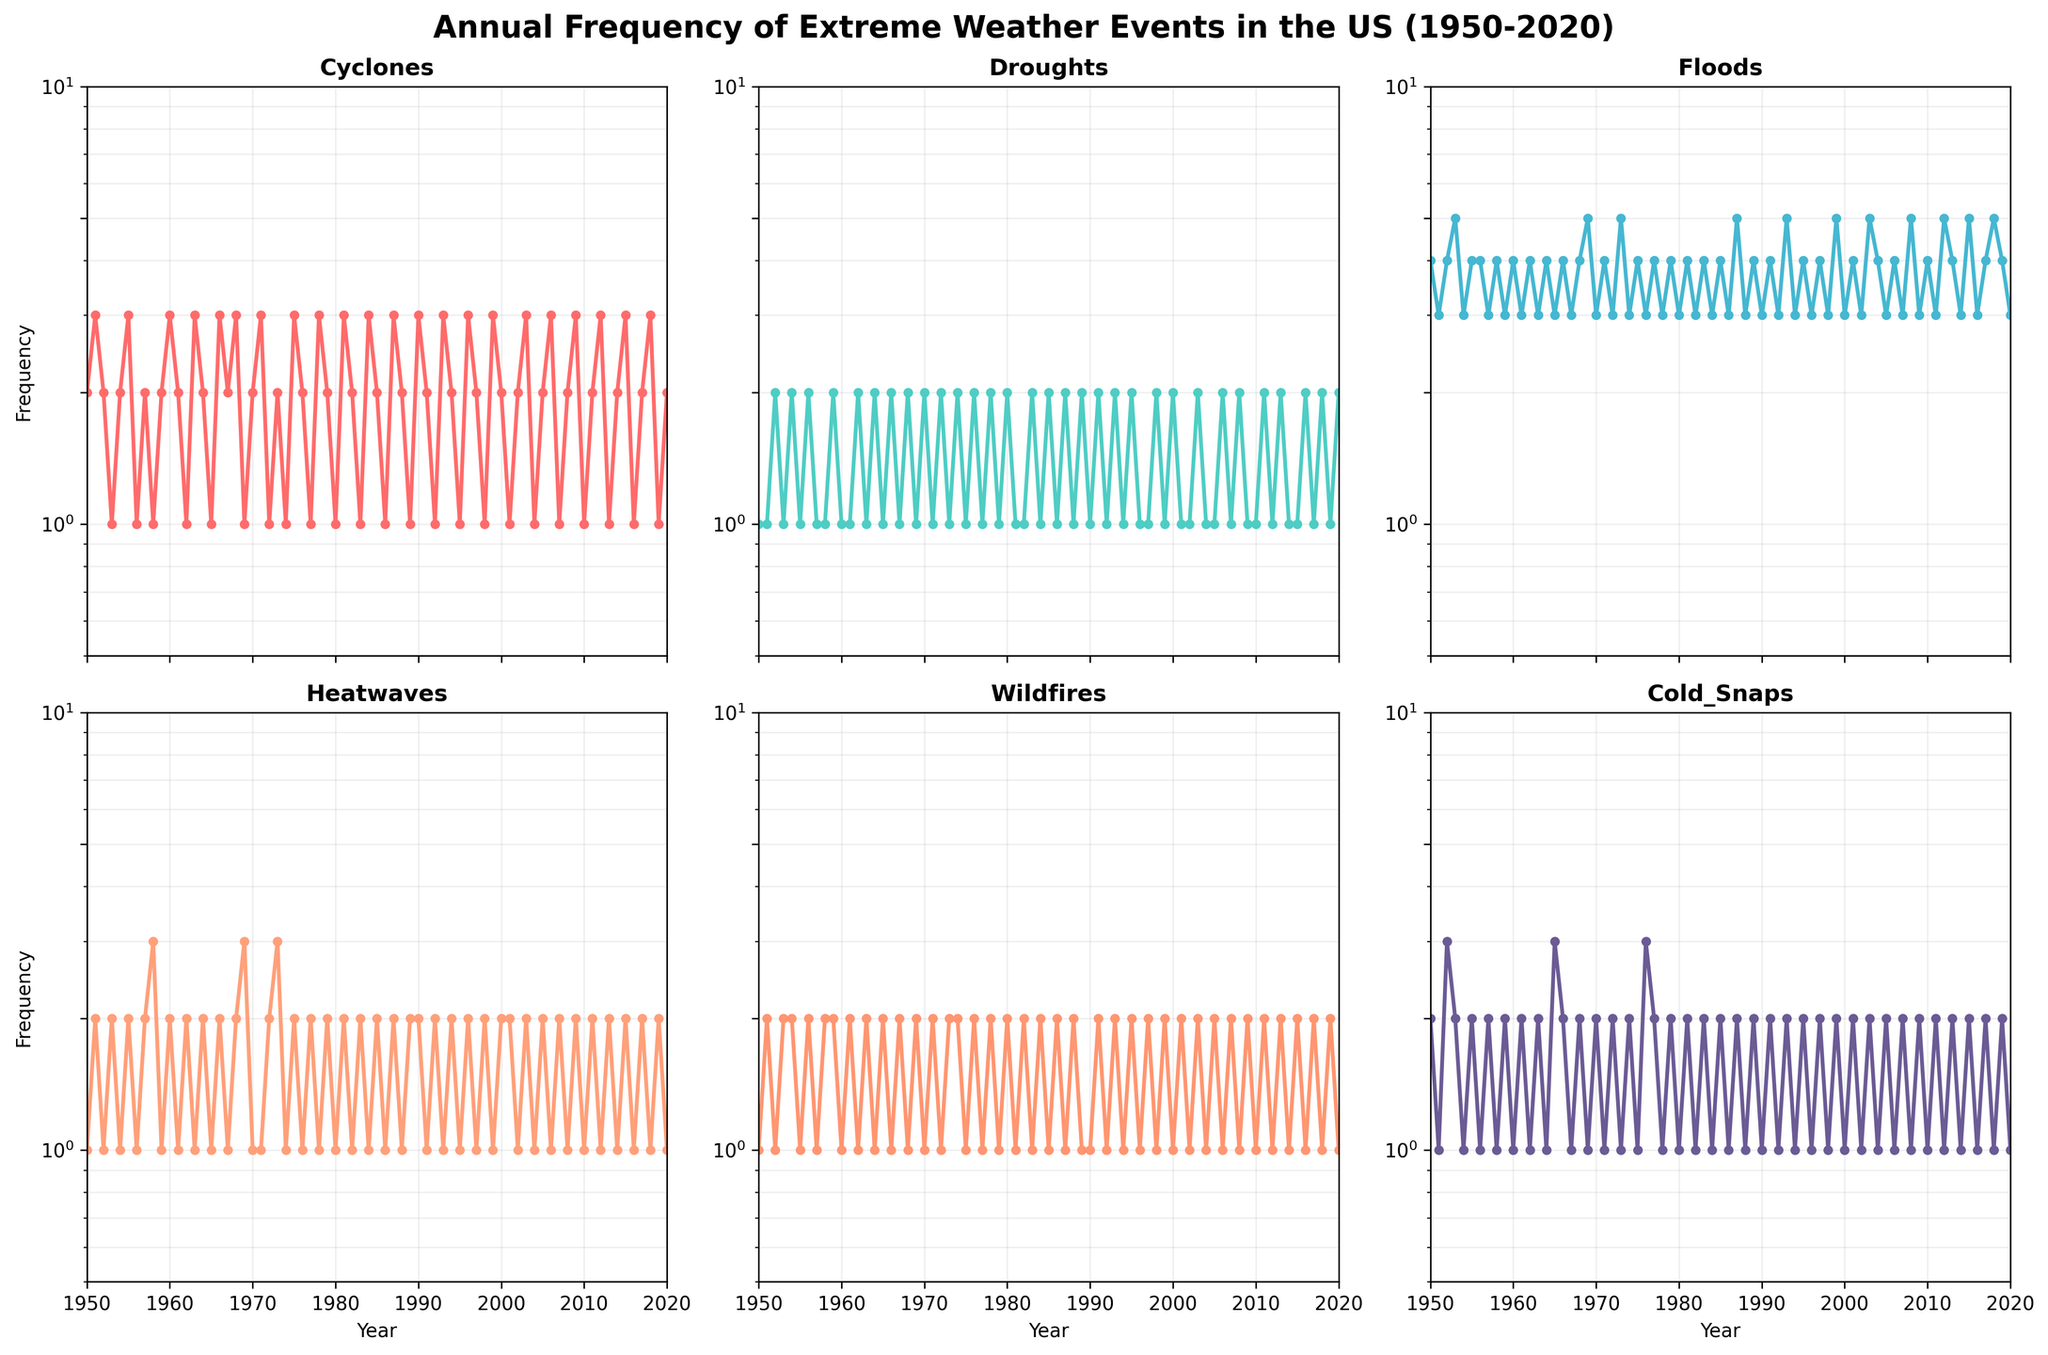What is the overall trend of cyclones from 1950 to 2020? The Cyclones subplot shows the frequency of cyclones over the years from 1950 to 2020. By observing the plot, we can identify any upward or downward trends in the frequency. The frequency of cyclones seems relatively consistent over the years without a strong increasing or decreasing trend.
Answer: Relatively consistent During which decade did wildfires occur most frequently? By looking at the Wildfires subplot, we can compare the frequency of events in each decade to identify which decade had the highest occurrence. The 2010s had the highest frequency of wildfires, with values often at or above 2 per year.
Answer: 2010s Which event had the most noticeable increase in frequency over the years? Examining all subplots, we can observe any events that show a clear upward trend over the years. Floods show the most noticeable increase in frequency, particularly from the late 1960s onwards.
Answer: Floods What is the frequency range of cold snaps? By looking at the y-axis of the Cold Snaps subplot, we determine the range of frequencies observed. The frequencies range between 1 and 3 per year.
Answer: 1 to 3 How do the frequencies of droughts and heatwaves compare in the 1970s? By examining the Droughts and Heatwaves subplots specifically for the years in the 1970s, we compare their yearly frequencies. Both droughts and heatwaves show variations in frequency but generally have similar patterns, fluctuating around 1 to 2 events per year.
Answer: Similar patterns, 1 to 2 events per year Which extreme weather event had the lowest frequency in 1969? Referring to the data points for 1969 across all subplots, we identify the extreme weather event with the lowest recorded frequency. Cyclones and Cold Snaps both had a frequency of 1 in 1969.
Answer: Cyclones and Cold Snaps What is the average frequency of cyclones in the 2000s? By looking at the Cyclones subplot and noting the frequencies for the years 2000-2009, we calculate the average: (2 + 1 + 2 + 3 + 1 + 2 + 3 + 1 + 2 + 3) / 10 = 2.
Answer: 2 Which event experienced the highest frequency in a single year, and what was the frequency? By examining all subplots, we identify the event with the highest single-year frequency. Floods in 1973 had the highest frequency at 5 events.
Answer: Floods, 5 events 